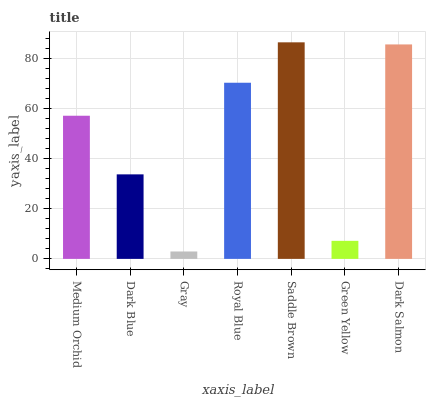Is Gray the minimum?
Answer yes or no. Yes. Is Saddle Brown the maximum?
Answer yes or no. Yes. Is Dark Blue the minimum?
Answer yes or no. No. Is Dark Blue the maximum?
Answer yes or no. No. Is Medium Orchid greater than Dark Blue?
Answer yes or no. Yes. Is Dark Blue less than Medium Orchid?
Answer yes or no. Yes. Is Dark Blue greater than Medium Orchid?
Answer yes or no. No. Is Medium Orchid less than Dark Blue?
Answer yes or no. No. Is Medium Orchid the high median?
Answer yes or no. Yes. Is Medium Orchid the low median?
Answer yes or no. Yes. Is Royal Blue the high median?
Answer yes or no. No. Is Green Yellow the low median?
Answer yes or no. No. 